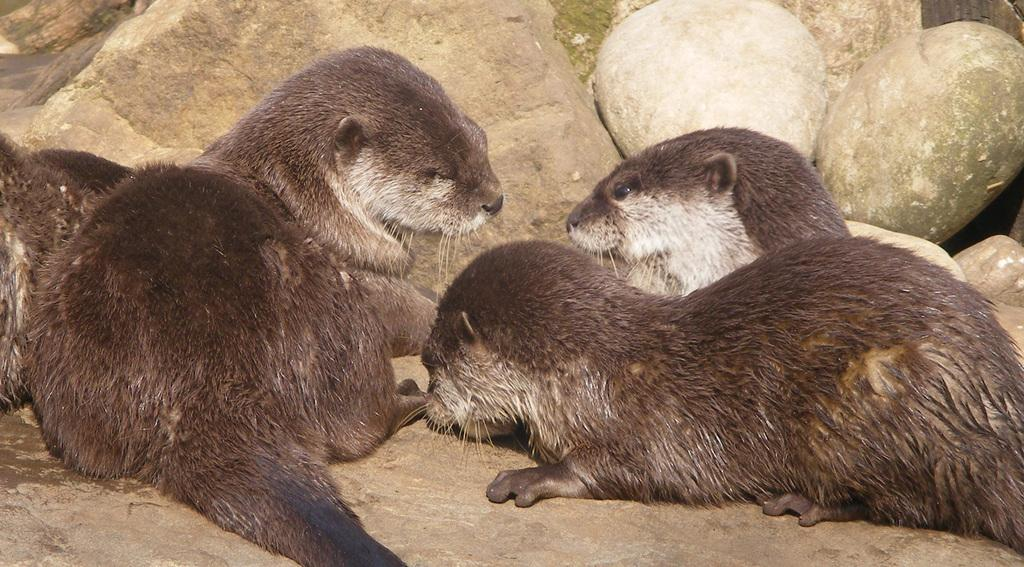What is lying on the surface in the image? There are animals lying on the surface in the image. What geological feature can be seen in the image? There is a rock visible in the image. What type of natural material is present in the image? There are stones present in the image. What type of book is being read by the animals in the image? There are no books or animals reading in the image; it only shows animals lying on the surface and a rock and stones nearby. 